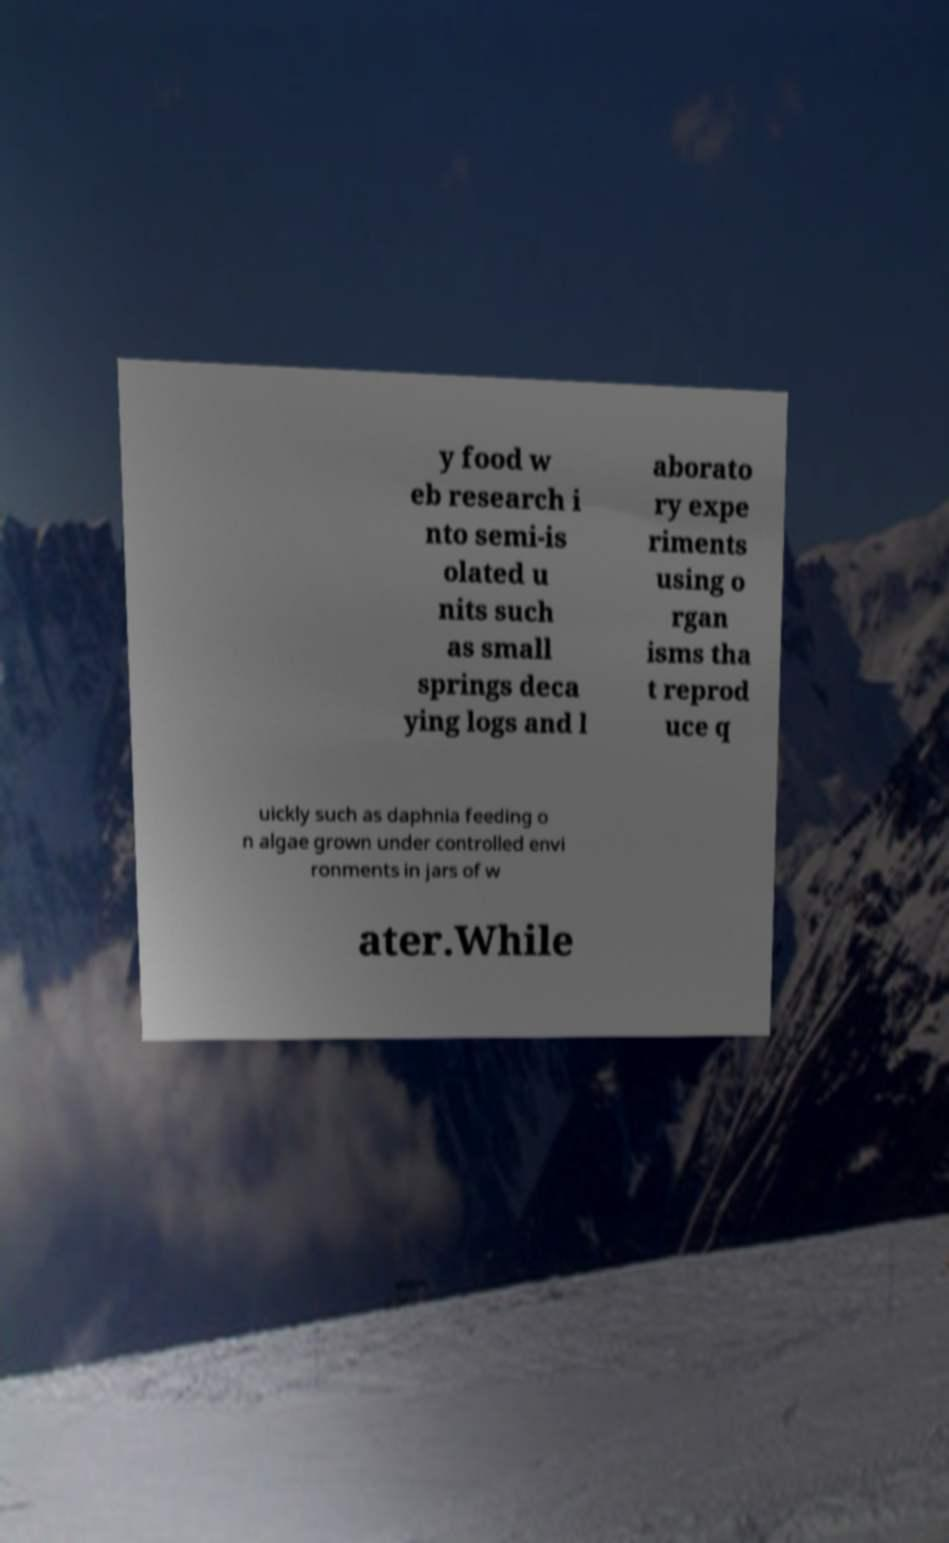Can you accurately transcribe the text from the provided image for me? y food w eb research i nto semi-is olated u nits such as small springs deca ying logs and l aborato ry expe riments using o rgan isms tha t reprod uce q uickly such as daphnia feeding o n algae grown under controlled envi ronments in jars of w ater.While 